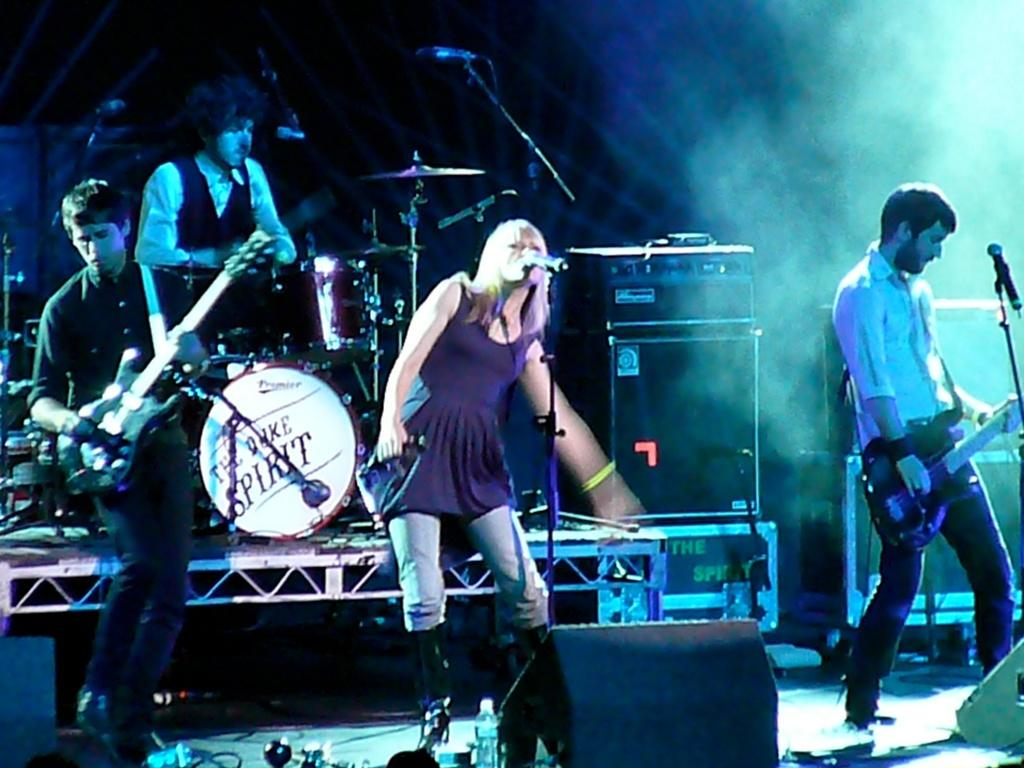What are the people in the image doing? The people in the image are playing musical instruments. Can you describe the girl in the image? The girl in the image is singing into a microphone. Where is the grandmother using the rake in the image? There is no grandmother or rake present in the image. What is the girl thinking about while singing into the microphone? The image does not provide information about the girl's thoughts or what she might be thinking about while singing. 